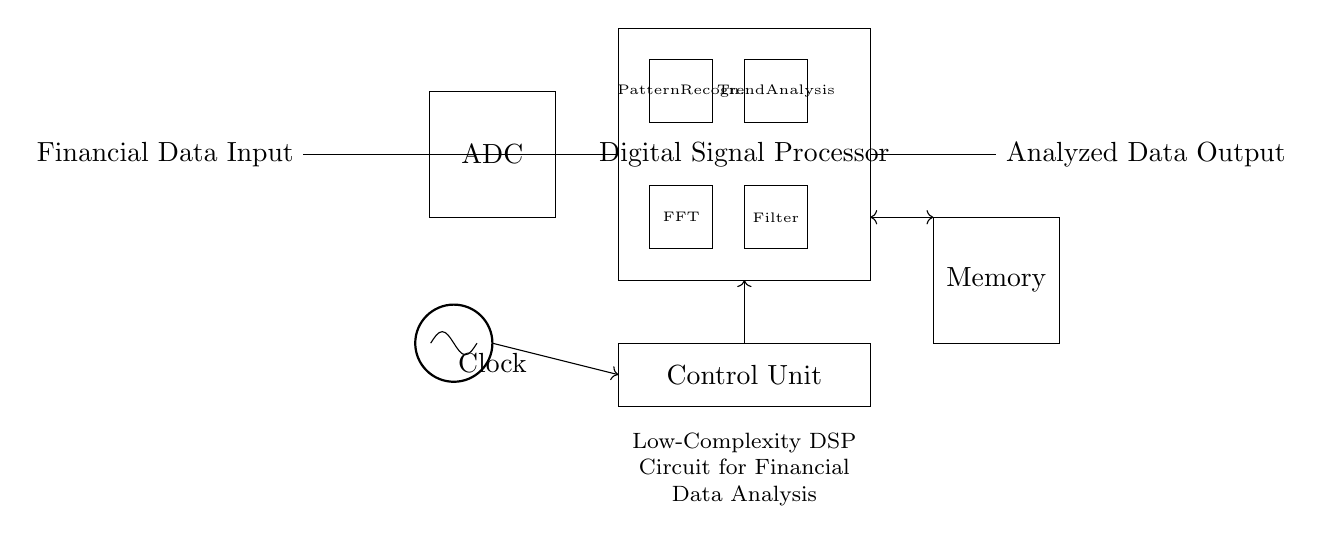What component converts the financial data input? The Analog-to-Digital Converter (ADC) is responsible for converting the analog financial data input into a digital format for further processing.
Answer: ADC What is the function of the Digital Signal Processor? The Digital Signal Processor processes the digitized financial data, performing operations like filtering, pattern recognition, and trend analysis to extract valuable insights.
Answer: Processing How many main components are in the Digital Signal Processor? There are four main components inside the Digital Signal Processor: FFT, Filter, Pattern Recognition, and Trend Analysis.
Answer: Four Which component generates the clock signal? The clock signal is generated by the oscillator positioned in the circuit diagram.
Answer: Oscillator In what part of the circuit is the memory located? The memory is located to the right side of the Digital Signal Processor and is connected to it, typically used to store processed data for later retrieval.
Answer: Right side How is the Control Unit connected to the Digital Signal Processor? The Control Unit is connected to the Digital Signal Processor via a direct control line indicated by the arrow pointing from the Control Unit to the Digital Signal Processor.
Answer: Directly What type of analysis does the circuit perform on financial data? The circuit is designed to perform pattern recognition and trend analysis on the financial data to identify significant trends and patterns.
Answer: Analysis 